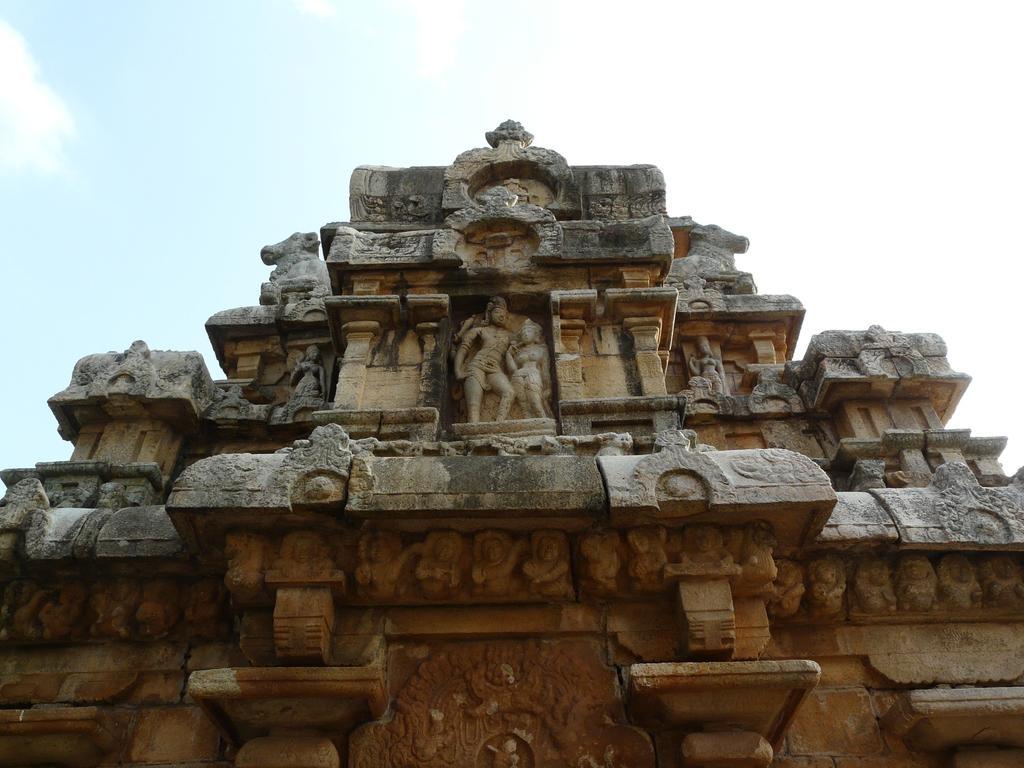Could you give a brief overview of what you see in this image? In this image we can see a monument. On the backside we can see the sky which looks cloudy. 